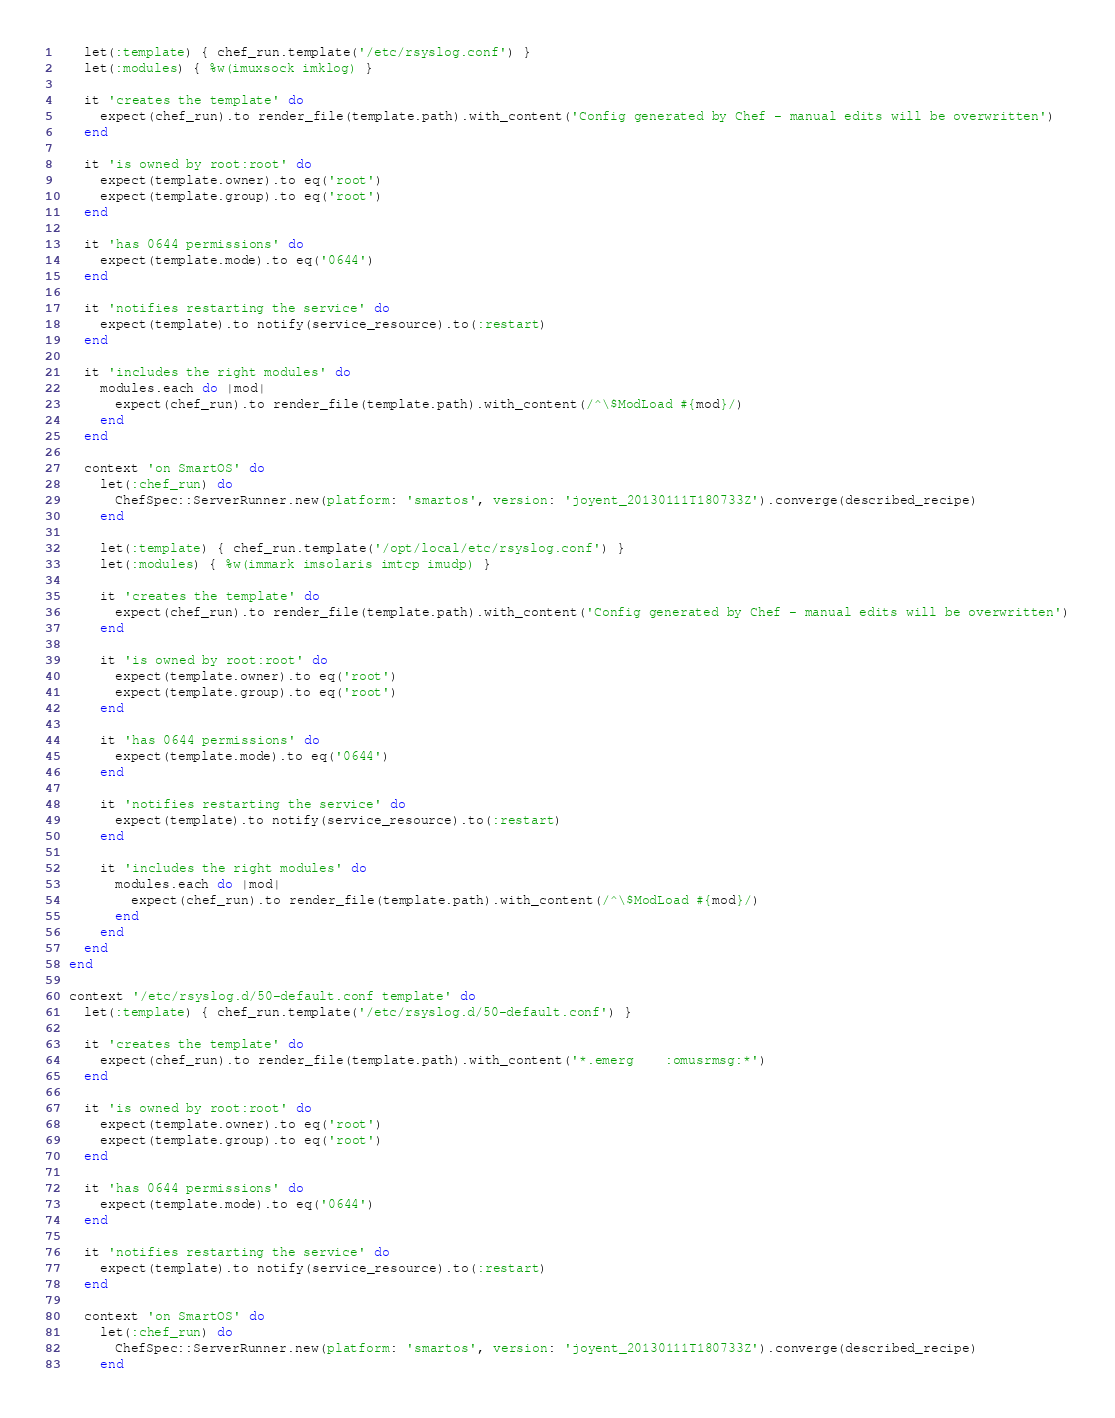Convert code to text. <code><loc_0><loc_0><loc_500><loc_500><_Ruby_>    let(:template) { chef_run.template('/etc/rsyslog.conf') }
    let(:modules) { %w(imuxsock imklog) }

    it 'creates the template' do
      expect(chef_run).to render_file(template.path).with_content('Config generated by Chef - manual edits will be overwritten')
    end

    it 'is owned by root:root' do
      expect(template.owner).to eq('root')
      expect(template.group).to eq('root')
    end

    it 'has 0644 permissions' do
      expect(template.mode).to eq('0644')
    end

    it 'notifies restarting the service' do
      expect(template).to notify(service_resource).to(:restart)
    end

    it 'includes the right modules' do
      modules.each do |mod|
        expect(chef_run).to render_file(template.path).with_content(/^\$ModLoad #{mod}/)
      end
    end

    context 'on SmartOS' do
      let(:chef_run) do
        ChefSpec::ServerRunner.new(platform: 'smartos', version: 'joyent_20130111T180733Z').converge(described_recipe)
      end

      let(:template) { chef_run.template('/opt/local/etc/rsyslog.conf') }
      let(:modules) { %w(immark imsolaris imtcp imudp) }

      it 'creates the template' do
        expect(chef_run).to render_file(template.path).with_content('Config generated by Chef - manual edits will be overwritten')
      end

      it 'is owned by root:root' do
        expect(template.owner).to eq('root')
        expect(template.group).to eq('root')
      end

      it 'has 0644 permissions' do
        expect(template.mode).to eq('0644')
      end

      it 'notifies restarting the service' do
        expect(template).to notify(service_resource).to(:restart)
      end

      it 'includes the right modules' do
        modules.each do |mod|
          expect(chef_run).to render_file(template.path).with_content(/^\$ModLoad #{mod}/)
        end
      end
    end
  end

  context '/etc/rsyslog.d/50-default.conf template' do
    let(:template) { chef_run.template('/etc/rsyslog.d/50-default.conf') }

    it 'creates the template' do
      expect(chef_run).to render_file(template.path).with_content('*.emerg    :omusrmsg:*')
    end

    it 'is owned by root:root' do
      expect(template.owner).to eq('root')
      expect(template.group).to eq('root')
    end

    it 'has 0644 permissions' do
      expect(template.mode).to eq('0644')
    end

    it 'notifies restarting the service' do
      expect(template).to notify(service_resource).to(:restart)
    end

    context 'on SmartOS' do
      let(:chef_run) do
        ChefSpec::ServerRunner.new(platform: 'smartos', version: 'joyent_20130111T180733Z').converge(described_recipe)
      end
</code> 